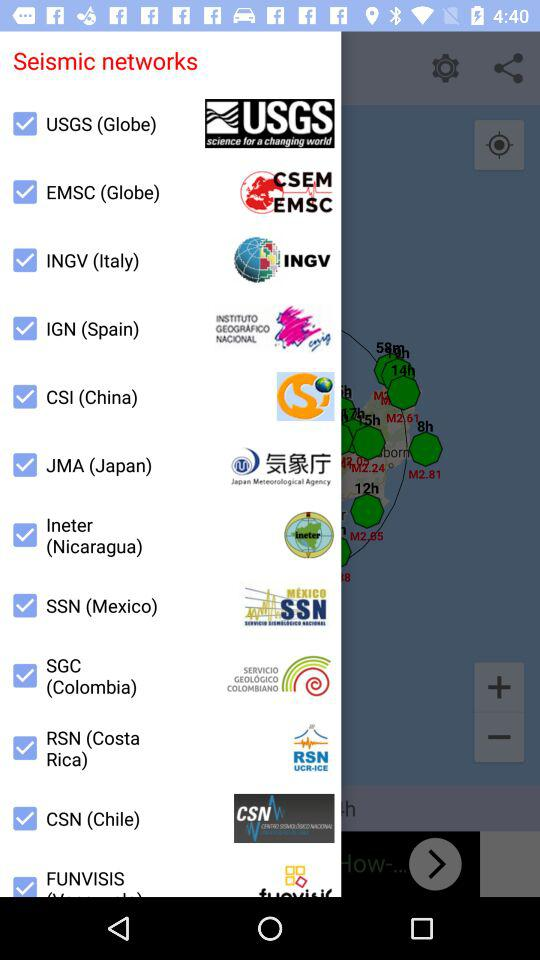Which country has a seismic network called CSI? The country China has a seismic network called CSI. 